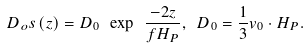Convert formula to latex. <formula><loc_0><loc_0><loc_500><loc_500>D _ { o } s \left ( z \right ) = D _ { 0 } \ \exp \ \frac { - 2 z } { f H _ { P } } , \ D _ { 0 } = \frac { 1 } { 3 } v _ { 0 } \cdot H _ { P } .</formula> 